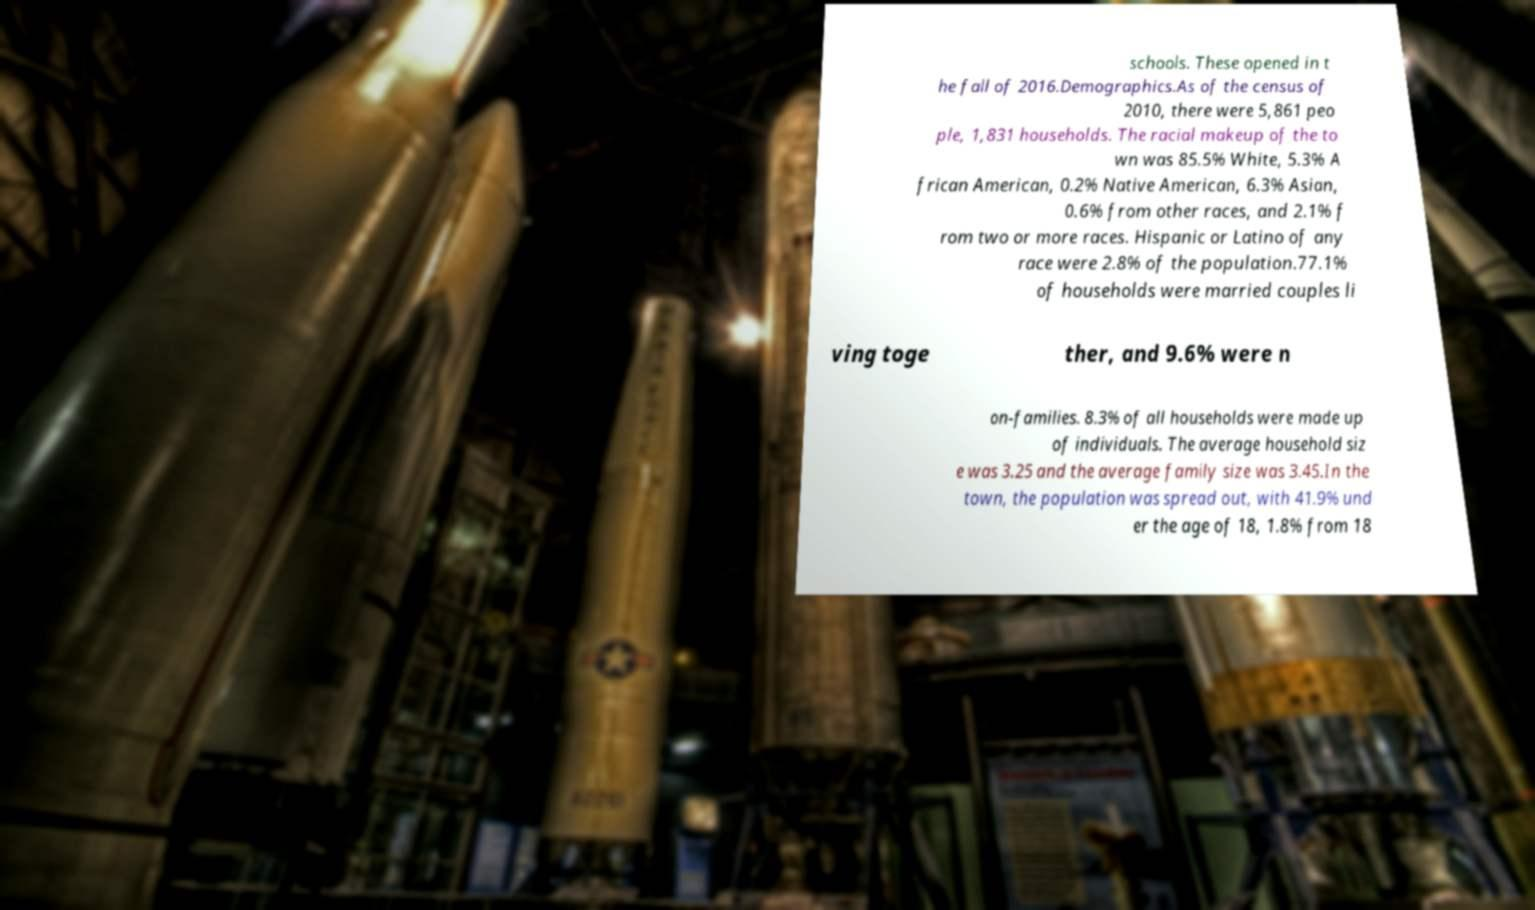For documentation purposes, I need the text within this image transcribed. Could you provide that? schools. These opened in t he fall of 2016.Demographics.As of the census of 2010, there were 5,861 peo ple, 1,831 households. The racial makeup of the to wn was 85.5% White, 5.3% A frican American, 0.2% Native American, 6.3% Asian, 0.6% from other races, and 2.1% f rom two or more races. Hispanic or Latino of any race were 2.8% of the population.77.1% of households were married couples li ving toge ther, and 9.6% were n on-families. 8.3% of all households were made up of individuals. The average household siz e was 3.25 and the average family size was 3.45.In the town, the population was spread out, with 41.9% und er the age of 18, 1.8% from 18 